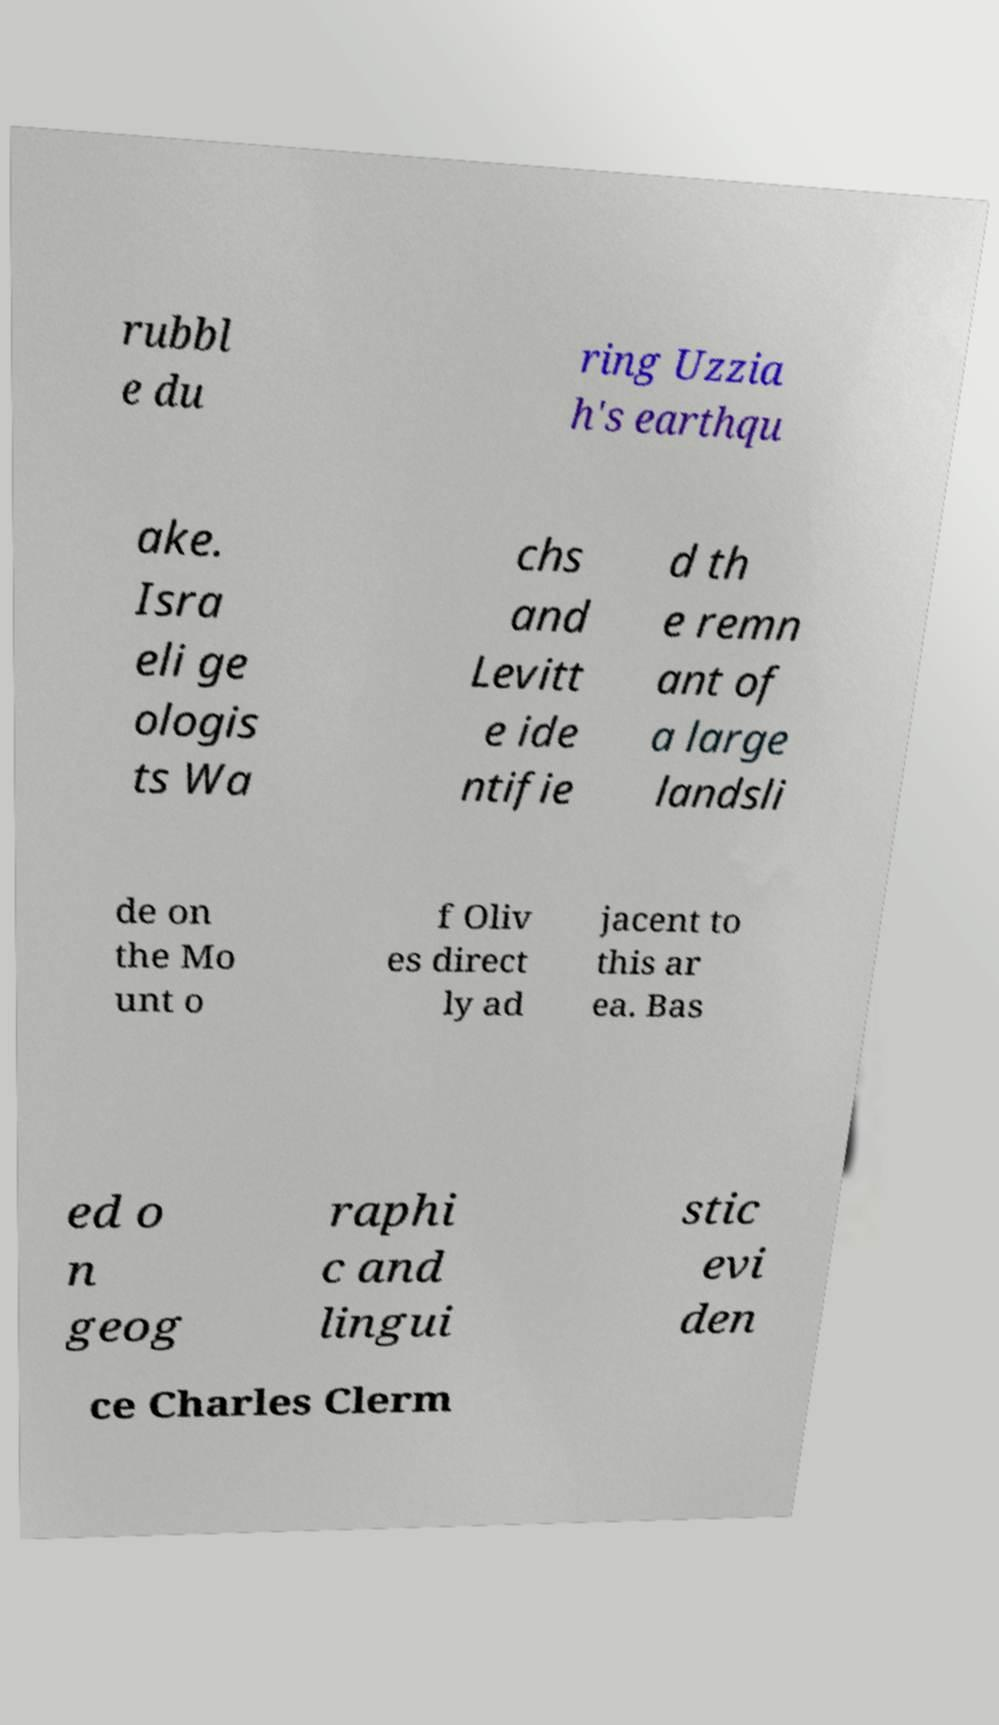Could you assist in decoding the text presented in this image and type it out clearly? rubbl e du ring Uzzia h's earthqu ake. Isra eli ge ologis ts Wa chs and Levitt e ide ntifie d th e remn ant of a large landsli de on the Mo unt o f Oliv es direct ly ad jacent to this ar ea. Bas ed o n geog raphi c and lingui stic evi den ce Charles Clerm 